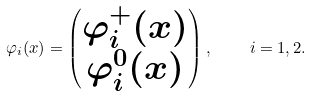<formula> <loc_0><loc_0><loc_500><loc_500>\varphi _ { i } ( x ) = \begin{pmatrix} \varphi ^ { + } _ { i } ( x ) \\ \varphi ^ { 0 } _ { i } ( x ) \end{pmatrix} , \quad i = 1 , 2 .</formula> 